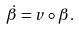<formula> <loc_0><loc_0><loc_500><loc_500>\dot { \beta } = v \circ \beta .</formula> 